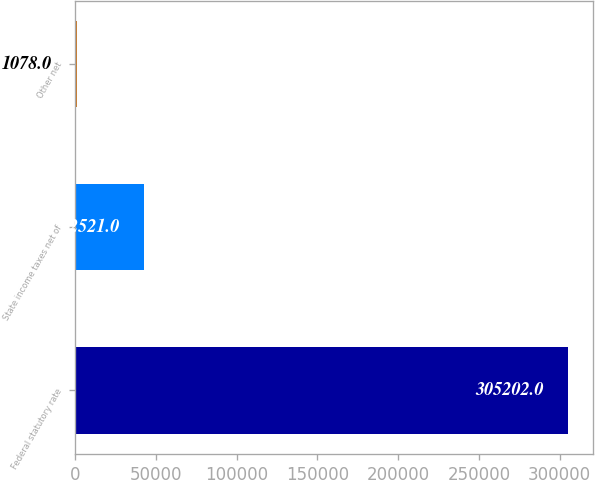Convert chart to OTSL. <chart><loc_0><loc_0><loc_500><loc_500><bar_chart><fcel>Federal statutory rate<fcel>State income taxes net of<fcel>Other net<nl><fcel>305202<fcel>42521<fcel>1078<nl></chart> 